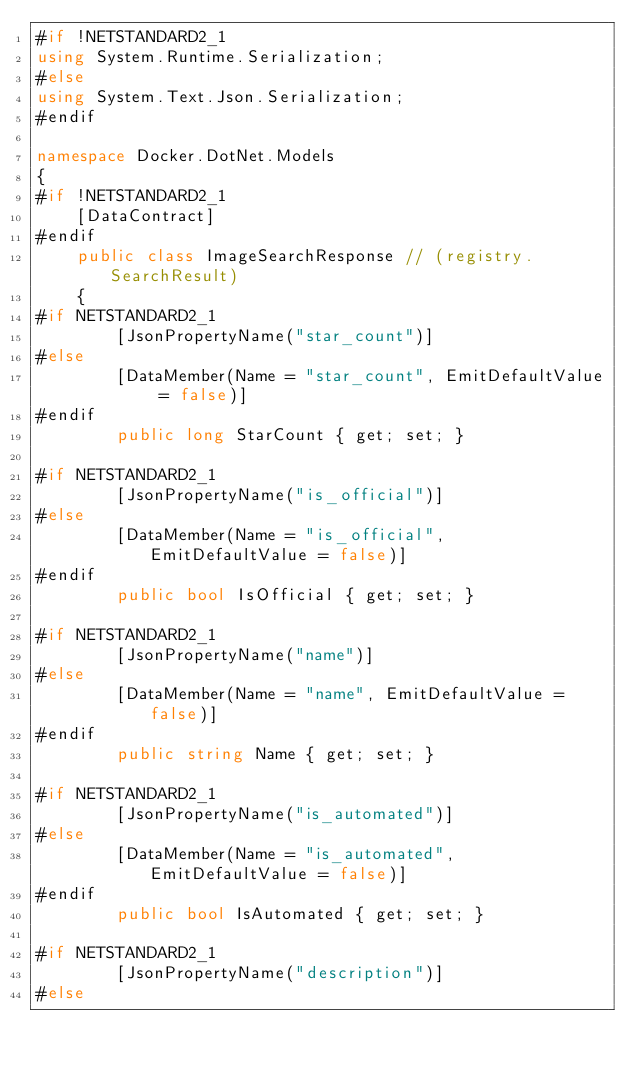Convert code to text. <code><loc_0><loc_0><loc_500><loc_500><_C#_>#if !NETSTANDARD2_1
using System.Runtime.Serialization;
#else
using System.Text.Json.Serialization;
#endif

namespace Docker.DotNet.Models
{
#if !NETSTANDARD2_1
    [DataContract]
#endif
    public class ImageSearchResponse // (registry.SearchResult)
    {
#if NETSTANDARD2_1
        [JsonPropertyName("star_count")]
#else
        [DataMember(Name = "star_count", EmitDefaultValue = false)]
#endif
        public long StarCount { get; set; }

#if NETSTANDARD2_1
        [JsonPropertyName("is_official")]
#else
        [DataMember(Name = "is_official", EmitDefaultValue = false)]
#endif
        public bool IsOfficial { get; set; }

#if NETSTANDARD2_1
        [JsonPropertyName("name")]
#else
        [DataMember(Name = "name", EmitDefaultValue = false)]
#endif
        public string Name { get; set; }

#if NETSTANDARD2_1
        [JsonPropertyName("is_automated")]
#else
        [DataMember(Name = "is_automated", EmitDefaultValue = false)]
#endif
        public bool IsAutomated { get; set; }

#if NETSTANDARD2_1
        [JsonPropertyName("description")]
#else</code> 